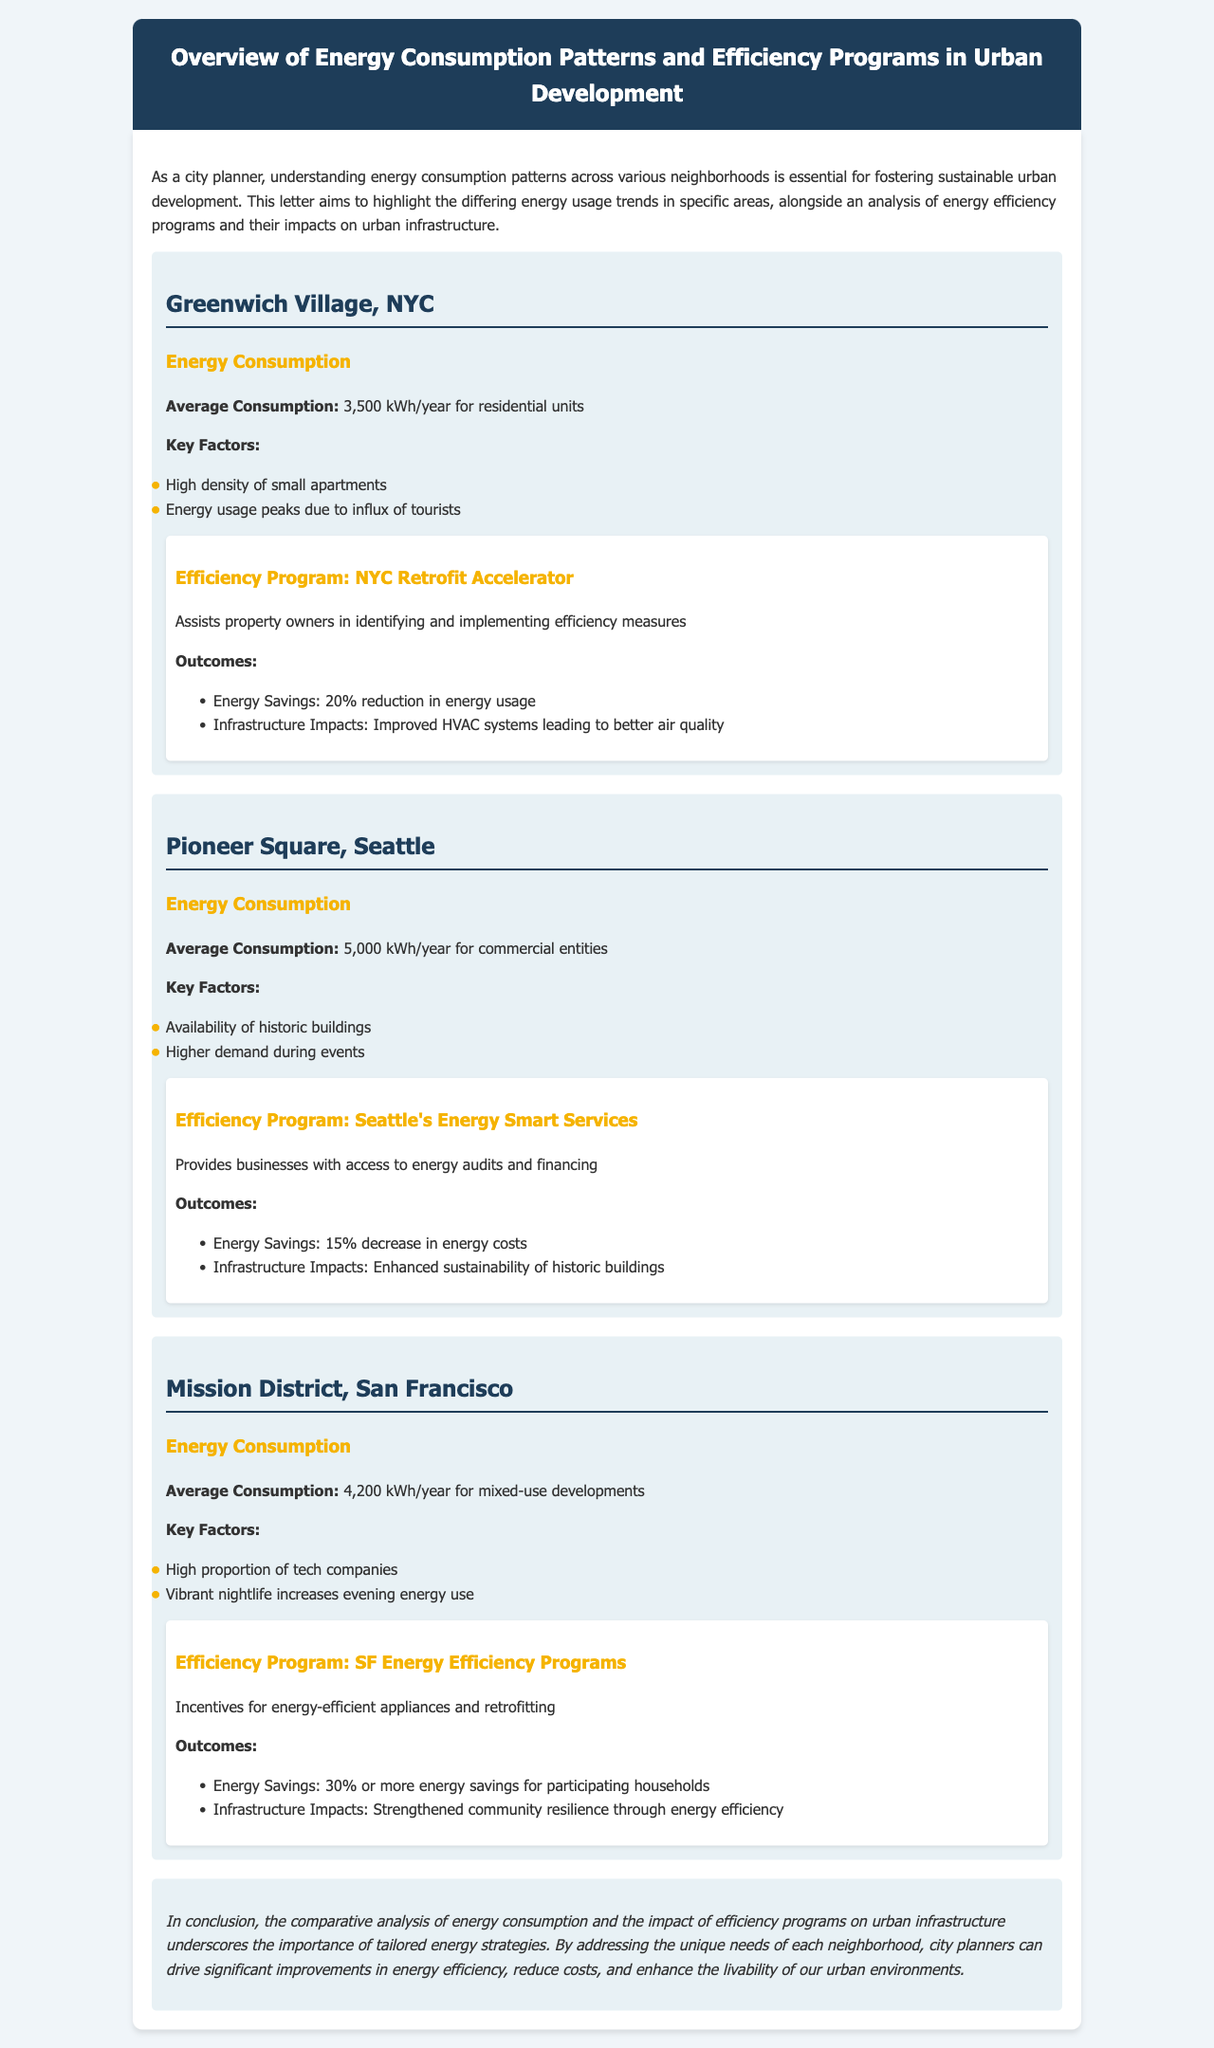What is the average energy consumption in Greenwich Village? The average energy consumption for residential units in Greenwich Village is stated in the document as 3,500 kWh/year.
Answer: 3,500 kWh/year What efficiency program is mentioned for Pioneer Square, Seattle? The document lists "Seattle's Energy Smart Services" as the efficiency program for Pioneer Square.
Answer: Seattle's Energy Smart Services What is the energy savings percentage for the Mission District's efficiency program? The document indicates that participating households in the Mission District's efficiency program achieve energy savings of 30% or more.
Answer: 30% Which neighborhood has the highest average energy consumption? By comparing the energy consumption figures, Pioneer Square, Seattle has the highest average consumption at 5,000 kWh/year for commercial entities.
Answer: Pioneer Square, Seattle What are the key factors for energy consumption in the Mission District? The key factors for energy consumption in the Mission District include a high proportion of tech companies and vibrant nightlife that increases energy use in the evening.
Answer: High proportion of tech companies, vibrant nightlife What infrastructure impact is mentioned for the NYC Retrofit Accelerator program? The document states that the NYC Retrofit Accelerator program leads to "improved HVAC systems leading to better air quality."
Answer: Improved HVAC systems, better air quality Which neighborhood has a significant influx of tourists affecting energy usage? The key factors section of the Greenwich Village description mentions that energy usage peaks due to an influx of tourists.
Answer: Greenwich Village What is a shared characteristic of the neighborhoods analyzed? All neighborhoods analyzed demonstrate distinct energy consumption patterns affected by local demographics and activities.
Answer: Distinct energy consumption patterns 